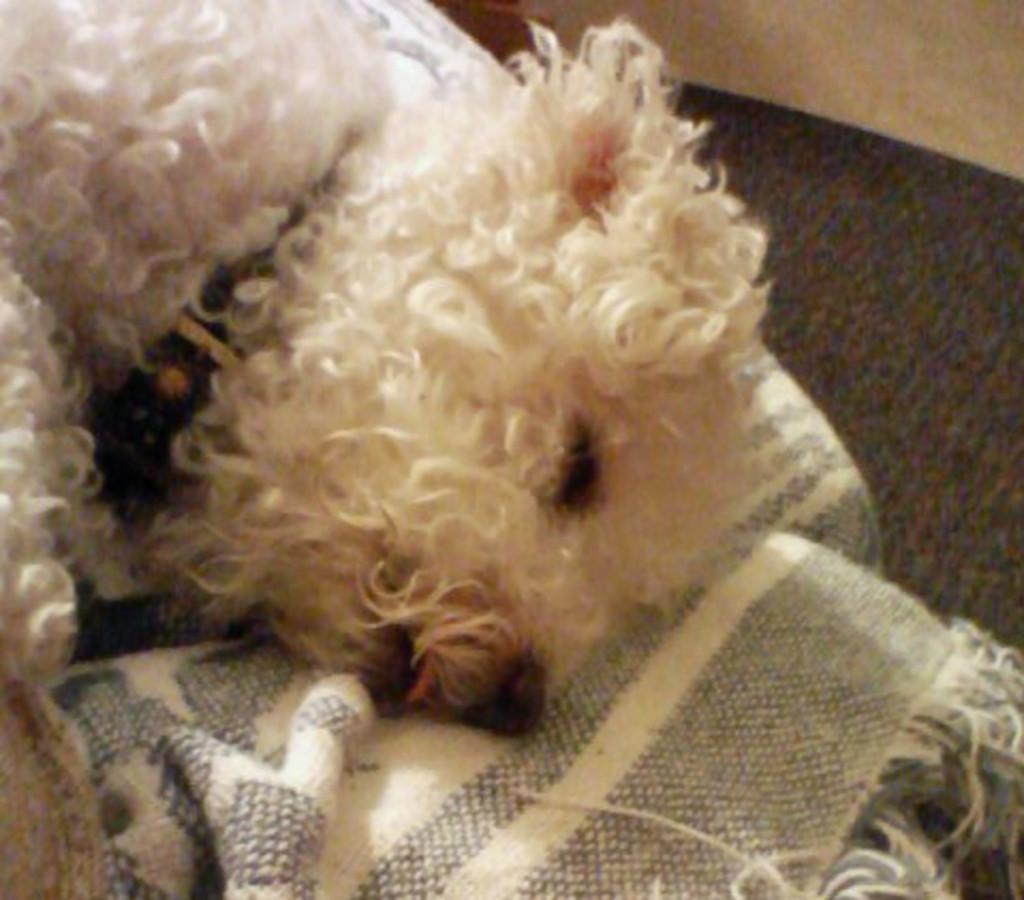What animal is present in the image? There is a dog in the image. What is the dog doing in the image? The dog is lying on a bed-sheet. What type of juice is being poured on the dog in the image? There is no juice being poured on the dog in the image; the dog is simply lying on a bed-sheet. 